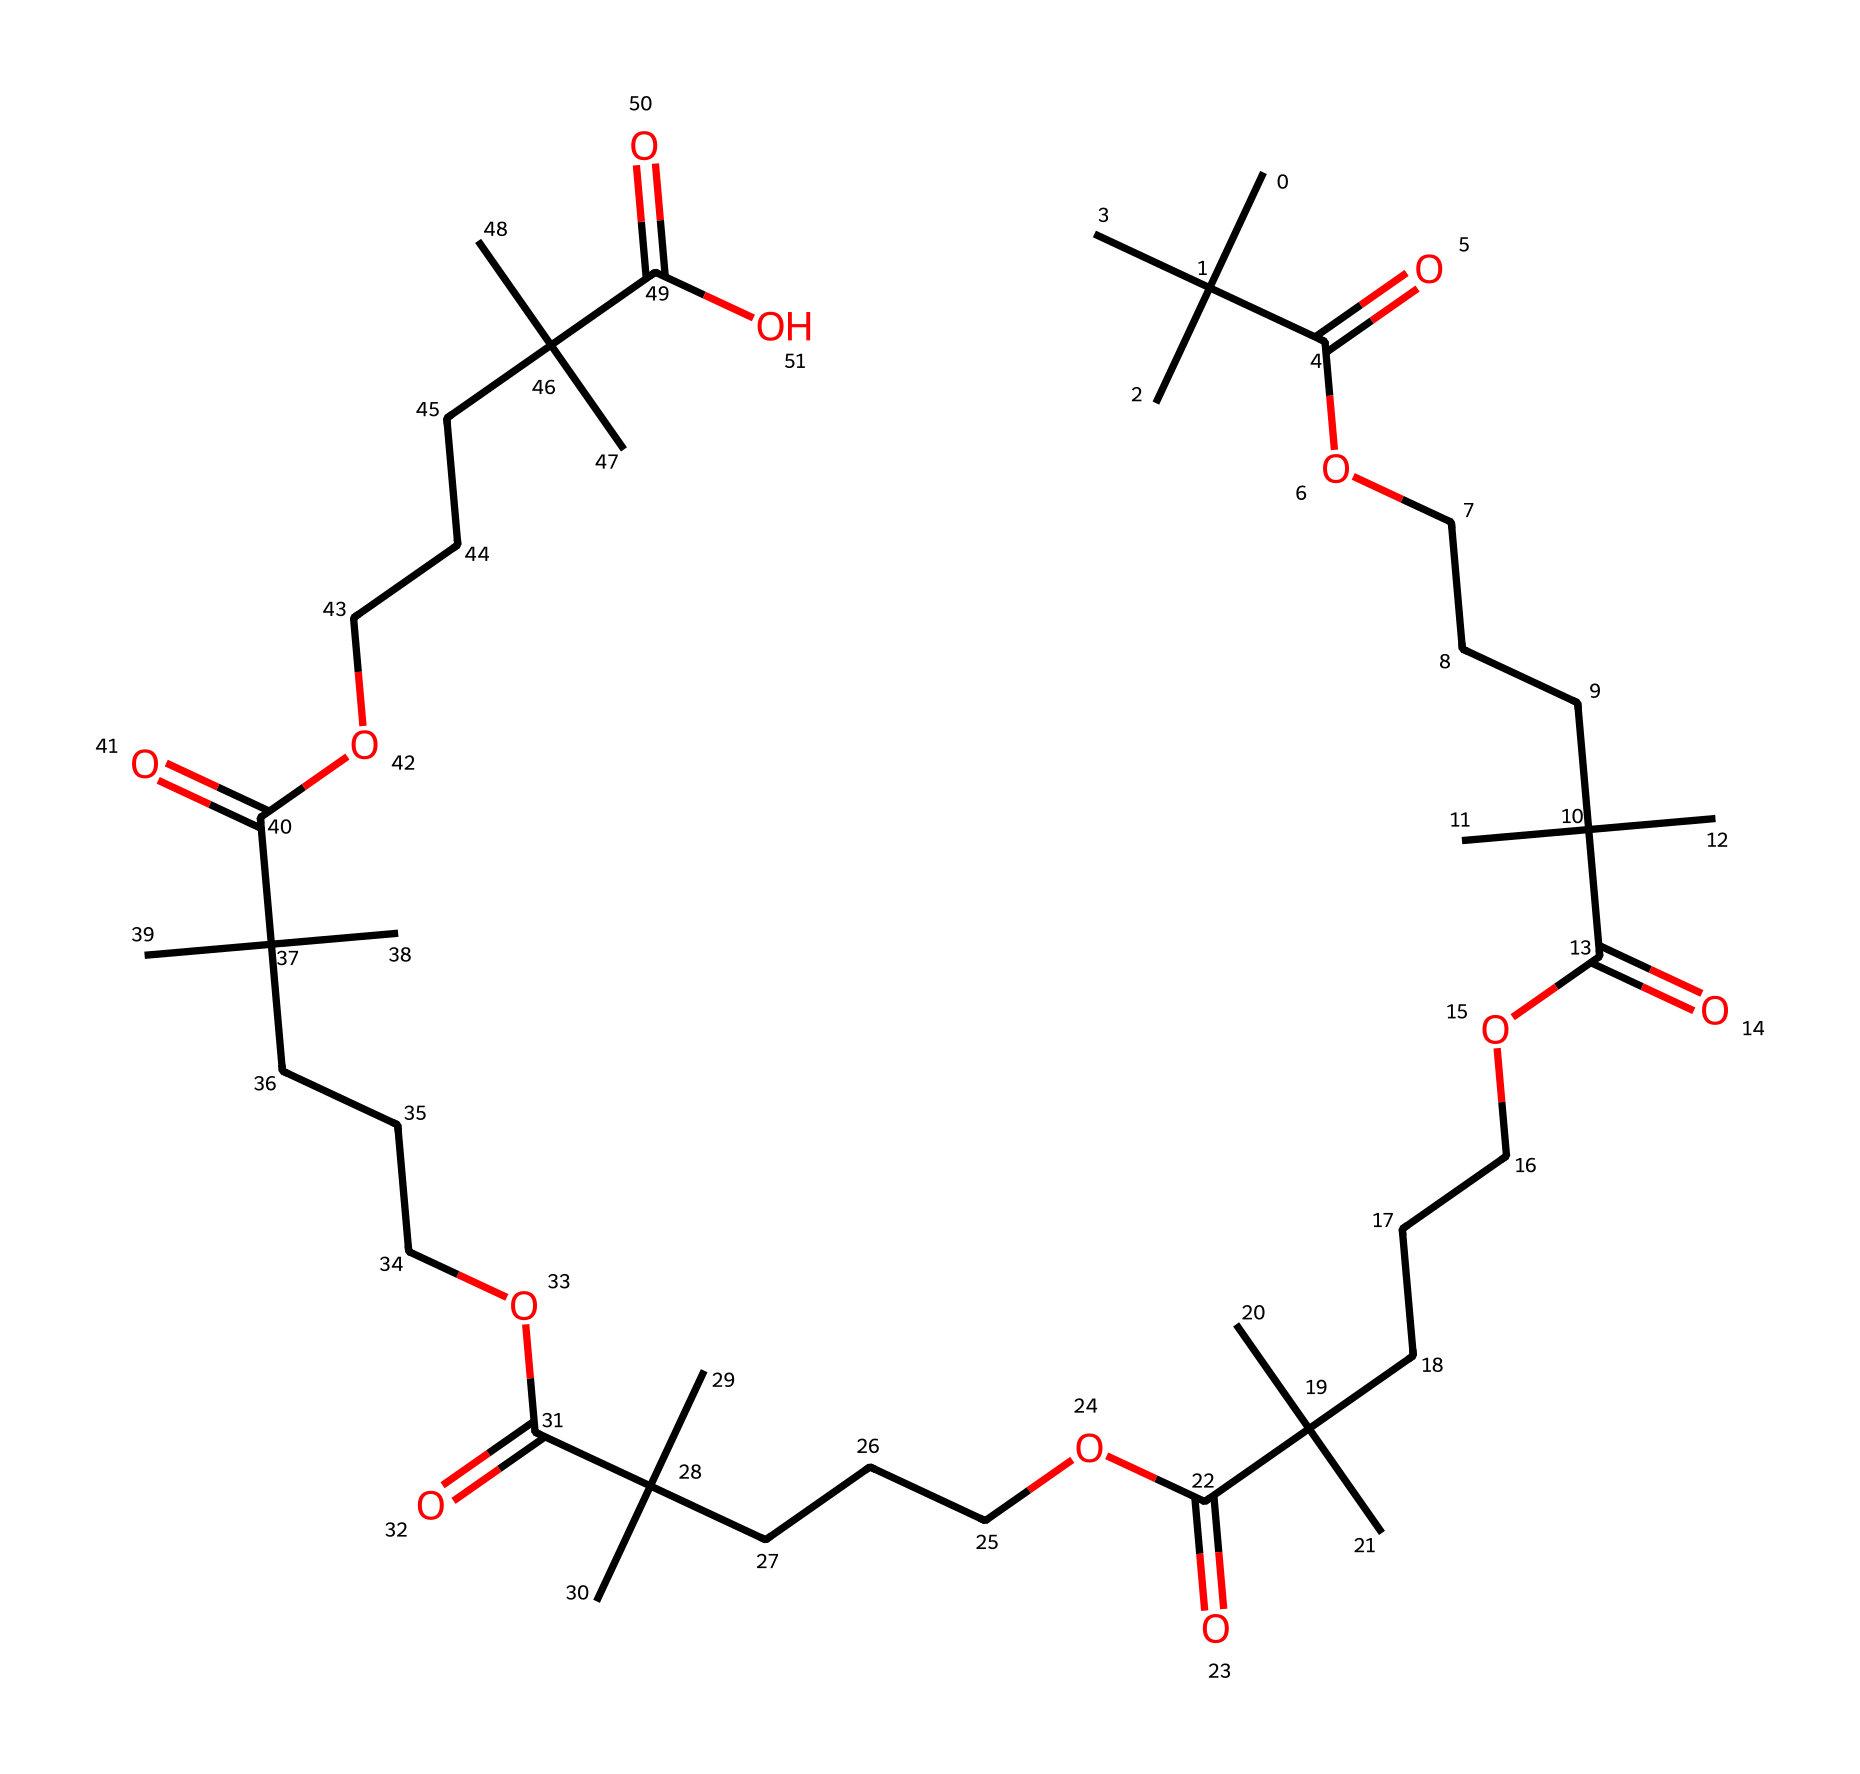how many carbon atoms are present in this molecule? By analyzing the provided SMILES representation, we can identify all instances of carbon atoms, which are represented by "C". Counting the occurrences in the sequence shows there are 30 carbon atoms in total.
Answer: 30 what type of functional groups are present in this chemical? The SMILES reveals carboxylic acid groups as indicated by the "C(=O)O" pattern, which appears six times in the structure. This indicates the presence of multiple carboxylic acid functional groups.
Answer: carboxylic acids is this chemical likely to exhibit viscoelastic properties? The presence of multiple repeating units and functional groups suggest that this polymeric structure can deform under stress and return to its original shape, characteristics typical of viscoelastic materials.
Answer: yes how does the presence of branching in the carbon chain affect its properties? The structure displays branching with groups of tertiary carbons, which can disrupt tight stacking in the polymer chains, leading to reduced viscosity and enhanced flexibility. This branching contributes to the viscoelastic nature of the substance.
Answer: reduced viscosity which structural feature contributes to the resistance against counterfeiting in this ink? The multiple carboxylic acid groups and long carbon chains contribute to unique interactions with pigments and dyes, resulting in complex flow behaviors that are less susceptible to replication, thus enhancing the anti-counterfeiting properties.
Answer: carboxylic acid groups what is the significance of the repeating unit in the polymer structure? The repeating units lend the polymer its characteristic viscoelastic properties, allowing it to respond to stress and strain while maintaining integrity. This chaining enhances durability, vital for banknote longevity.
Answer: durability 